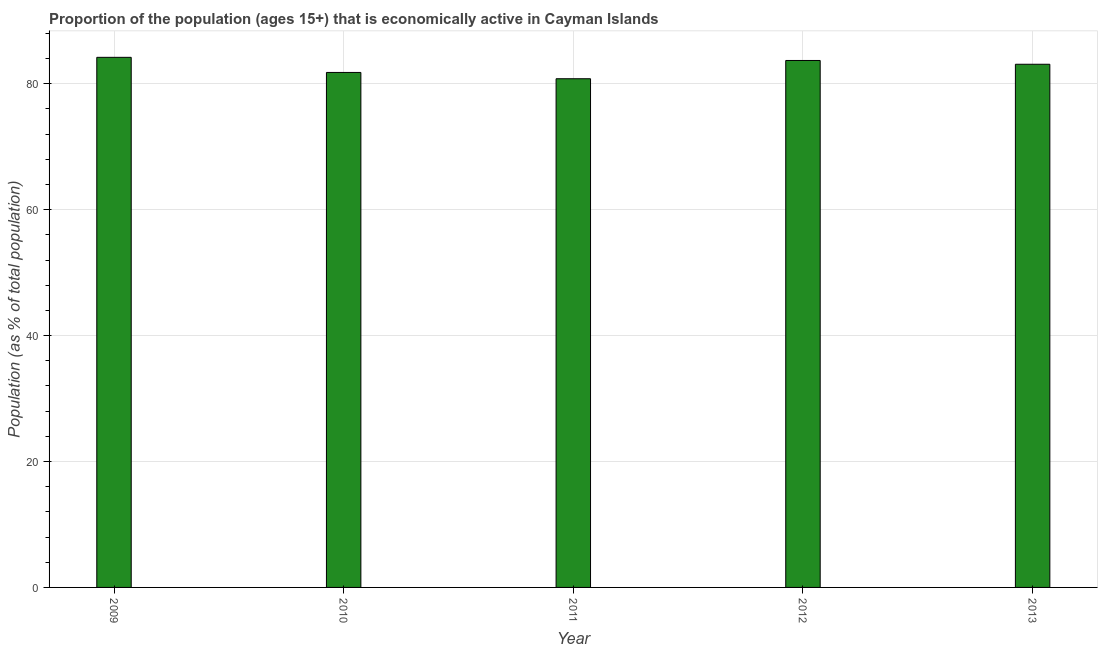Does the graph contain grids?
Your answer should be very brief. Yes. What is the title of the graph?
Offer a very short reply. Proportion of the population (ages 15+) that is economically active in Cayman Islands. What is the label or title of the Y-axis?
Keep it short and to the point. Population (as % of total population). What is the percentage of economically active population in 2012?
Offer a very short reply. 83.7. Across all years, what is the maximum percentage of economically active population?
Offer a very short reply. 84.2. Across all years, what is the minimum percentage of economically active population?
Your response must be concise. 80.8. In which year was the percentage of economically active population maximum?
Offer a very short reply. 2009. What is the sum of the percentage of economically active population?
Give a very brief answer. 413.6. What is the difference between the percentage of economically active population in 2009 and 2010?
Your answer should be compact. 2.4. What is the average percentage of economically active population per year?
Your answer should be compact. 82.72. What is the median percentage of economically active population?
Your response must be concise. 83.1. In how many years, is the percentage of economically active population greater than 68 %?
Make the answer very short. 5. What is the ratio of the percentage of economically active population in 2011 to that in 2012?
Offer a terse response. 0.96. Is the percentage of economically active population in 2010 less than that in 2013?
Provide a short and direct response. Yes. Are all the bars in the graph horizontal?
Give a very brief answer. No. What is the difference between two consecutive major ticks on the Y-axis?
Make the answer very short. 20. What is the Population (as % of total population) in 2009?
Provide a short and direct response. 84.2. What is the Population (as % of total population) of 2010?
Give a very brief answer. 81.8. What is the Population (as % of total population) in 2011?
Your answer should be very brief. 80.8. What is the Population (as % of total population) in 2012?
Keep it short and to the point. 83.7. What is the Population (as % of total population) in 2013?
Offer a very short reply. 83.1. What is the difference between the Population (as % of total population) in 2009 and 2010?
Offer a terse response. 2.4. What is the difference between the Population (as % of total population) in 2009 and 2011?
Give a very brief answer. 3.4. What is the difference between the Population (as % of total population) in 2009 and 2012?
Make the answer very short. 0.5. What is the difference between the Population (as % of total population) in 2009 and 2013?
Keep it short and to the point. 1.1. What is the difference between the Population (as % of total population) in 2010 and 2012?
Offer a terse response. -1.9. What is the difference between the Population (as % of total population) in 2010 and 2013?
Your answer should be compact. -1.3. What is the difference between the Population (as % of total population) in 2011 and 2012?
Give a very brief answer. -2.9. What is the ratio of the Population (as % of total population) in 2009 to that in 2010?
Your response must be concise. 1.03. What is the ratio of the Population (as % of total population) in 2009 to that in 2011?
Give a very brief answer. 1.04. What is the ratio of the Population (as % of total population) in 2009 to that in 2012?
Give a very brief answer. 1.01. What is the ratio of the Population (as % of total population) in 2009 to that in 2013?
Your answer should be compact. 1.01. What is the ratio of the Population (as % of total population) in 2010 to that in 2012?
Provide a short and direct response. 0.98. What is the ratio of the Population (as % of total population) in 2011 to that in 2013?
Your answer should be compact. 0.97. 